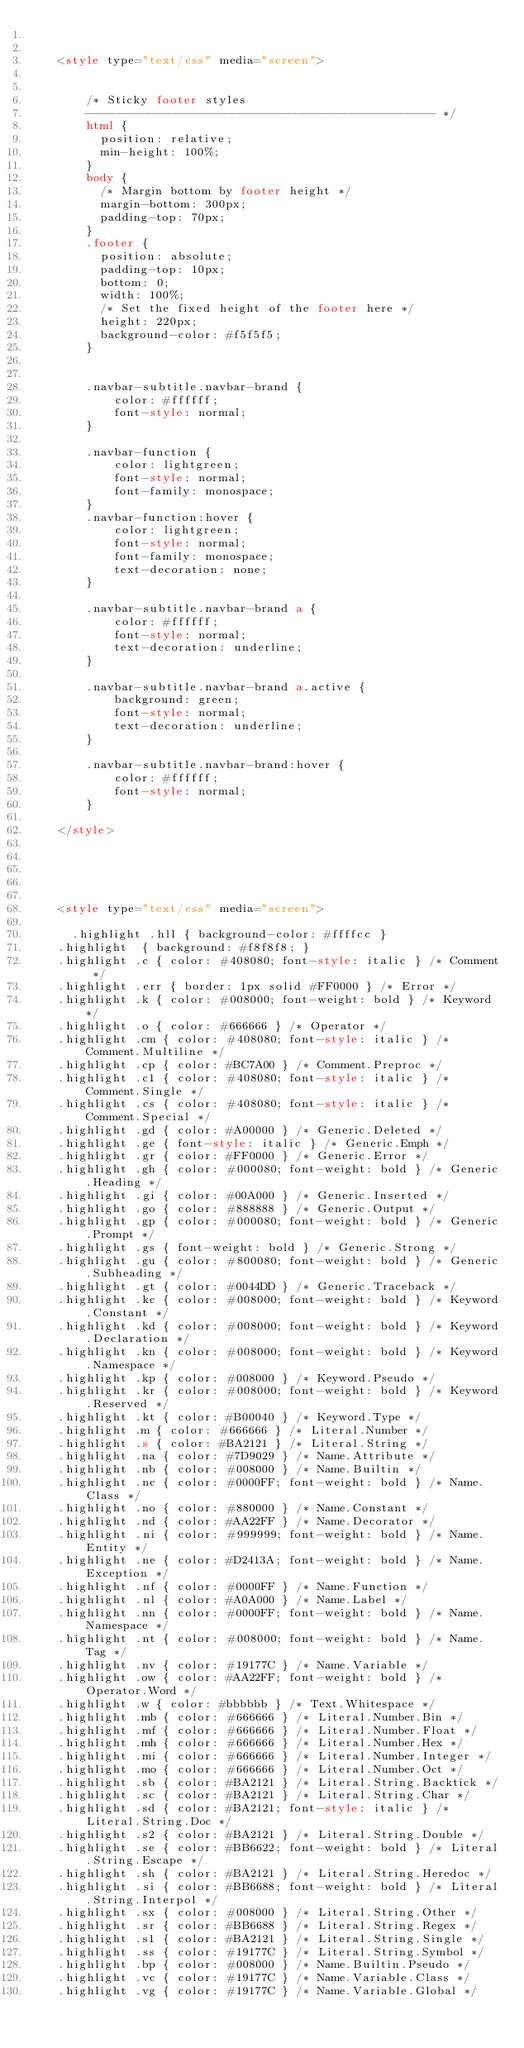Convert code to text. <code><loc_0><loc_0><loc_500><loc_500><_HTML_>		
		
	<style type="text/css" media="screen">


		/* Sticky footer styles 
		-------------------------------------------------- */
		html {
		  position: relative;
		  min-height: 100%;
		}
		body {
		  /* Margin bottom by footer height */
		  margin-bottom: 300px;
		  padding-top: 70px;
		}
		.footer {
		  position: absolute;
		  padding-top: 10px;
		  bottom: 0;
		  width: 100%;
		  /* Set the fixed height of the footer here */
		  height: 220px;
		  background-color: #f5f5f5;
		}
		

		.navbar-subtitle.navbar-brand {
			color: #ffffff;
			font-style: normal;
		}

		.navbar-function {
			color: lightgreen;
			font-style: normal;
			font-family: monospace;
		}
		.navbar-function:hover {
			color: lightgreen;
			font-style: normal;
			font-family: monospace;
			text-decoration: none;
		}
		
		.navbar-subtitle.navbar-brand a {
			color: #ffffff;
			font-style: normal;
			text-decoration: underline;
		}

		.navbar-subtitle.navbar-brand a.active {
			background: green;
			font-style: normal;
			text-decoration: underline;
		}

		.navbar-subtitle.navbar-brand:hover {
			color: #ffffff;
			font-style: normal;
		}
		
	</style>	
		
		
	
	
	
	<style type="text/css" media="screen">

	  .highlight .hll { background-color: #ffffcc }
	.highlight  { background: #f8f8f8; }
	.highlight .c { color: #408080; font-style: italic } /* Comment */
	.highlight .err { border: 1px solid #FF0000 } /* Error */
	.highlight .k { color: #008000; font-weight: bold } /* Keyword */
	.highlight .o { color: #666666 } /* Operator */
	.highlight .cm { color: #408080; font-style: italic } /* Comment.Multiline */
	.highlight .cp { color: #BC7A00 } /* Comment.Preproc */
	.highlight .c1 { color: #408080; font-style: italic } /* Comment.Single */
	.highlight .cs { color: #408080; font-style: italic } /* Comment.Special */
	.highlight .gd { color: #A00000 } /* Generic.Deleted */
	.highlight .ge { font-style: italic } /* Generic.Emph */
	.highlight .gr { color: #FF0000 } /* Generic.Error */
	.highlight .gh { color: #000080; font-weight: bold } /* Generic.Heading */
	.highlight .gi { color: #00A000 } /* Generic.Inserted */
	.highlight .go { color: #888888 } /* Generic.Output */
	.highlight .gp { color: #000080; font-weight: bold } /* Generic.Prompt */
	.highlight .gs { font-weight: bold } /* Generic.Strong */
	.highlight .gu { color: #800080; font-weight: bold } /* Generic.Subheading */
	.highlight .gt { color: #0044DD } /* Generic.Traceback */
	.highlight .kc { color: #008000; font-weight: bold } /* Keyword.Constant */
	.highlight .kd { color: #008000; font-weight: bold } /* Keyword.Declaration */
	.highlight .kn { color: #008000; font-weight: bold } /* Keyword.Namespace */
	.highlight .kp { color: #008000 } /* Keyword.Pseudo */
	.highlight .kr { color: #008000; font-weight: bold } /* Keyword.Reserved */
	.highlight .kt { color: #B00040 } /* Keyword.Type */
	.highlight .m { color: #666666 } /* Literal.Number */
	.highlight .s { color: #BA2121 } /* Literal.String */
	.highlight .na { color: #7D9029 } /* Name.Attribute */
	.highlight .nb { color: #008000 } /* Name.Builtin */
	.highlight .nc { color: #0000FF; font-weight: bold } /* Name.Class */
	.highlight .no { color: #880000 } /* Name.Constant */
	.highlight .nd { color: #AA22FF } /* Name.Decorator */
	.highlight .ni { color: #999999; font-weight: bold } /* Name.Entity */
	.highlight .ne { color: #D2413A; font-weight: bold } /* Name.Exception */
	.highlight .nf { color: #0000FF } /* Name.Function */
	.highlight .nl { color: #A0A000 } /* Name.Label */
	.highlight .nn { color: #0000FF; font-weight: bold } /* Name.Namespace */
	.highlight .nt { color: #008000; font-weight: bold } /* Name.Tag */
	.highlight .nv { color: #19177C } /* Name.Variable */
	.highlight .ow { color: #AA22FF; font-weight: bold } /* Operator.Word */
	.highlight .w { color: #bbbbbb } /* Text.Whitespace */
	.highlight .mb { color: #666666 } /* Literal.Number.Bin */
	.highlight .mf { color: #666666 } /* Literal.Number.Float */
	.highlight .mh { color: #666666 } /* Literal.Number.Hex */
	.highlight .mi { color: #666666 } /* Literal.Number.Integer */
	.highlight .mo { color: #666666 } /* Literal.Number.Oct */
	.highlight .sb { color: #BA2121 } /* Literal.String.Backtick */
	.highlight .sc { color: #BA2121 } /* Literal.String.Char */
	.highlight .sd { color: #BA2121; font-style: italic } /* Literal.String.Doc */
	.highlight .s2 { color: #BA2121 } /* Literal.String.Double */
	.highlight .se { color: #BB6622; font-weight: bold } /* Literal.String.Escape */
	.highlight .sh { color: #BA2121 } /* Literal.String.Heredoc */
	.highlight .si { color: #BB6688; font-weight: bold } /* Literal.String.Interpol */
	.highlight .sx { color: #008000 } /* Literal.String.Other */
	.highlight .sr { color: #BB6688 } /* Literal.String.Regex */
	.highlight .s1 { color: #BA2121 } /* Literal.String.Single */
	.highlight .ss { color: #19177C } /* Literal.String.Symbol */
	.highlight .bp { color: #008000 } /* Name.Builtin.Pseudo */
	.highlight .vc { color: #19177C } /* Name.Variable.Class */
	.highlight .vg { color: #19177C } /* Name.Variable.Global */</code> 